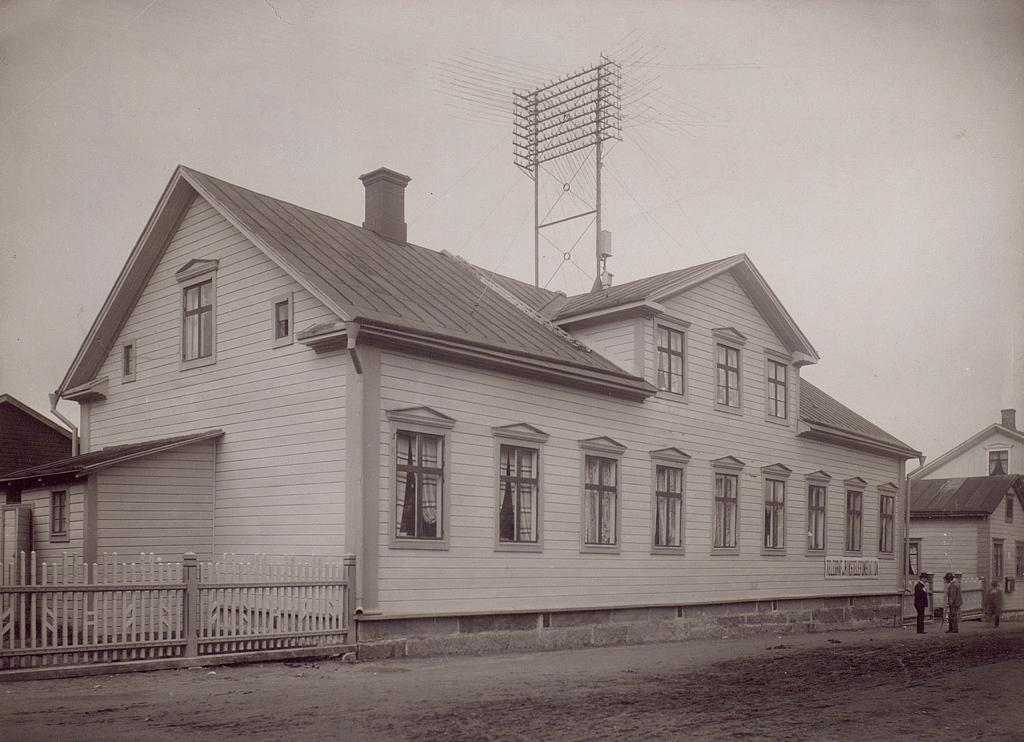What type of structure is present in the image? There is a building in the image. What can be seen in the background of the image? The sky is visible in the image. Are there any people present in the image? Yes, there are people standing in the image. What is the color scheme of the image? The image is in black and white. Where is the bucket located in the image? There is no bucket present in the image. What type of mitten is being worn by the people in the image? There is no mitten visible in the image, as it is in black and white and does not show any clothing details. 